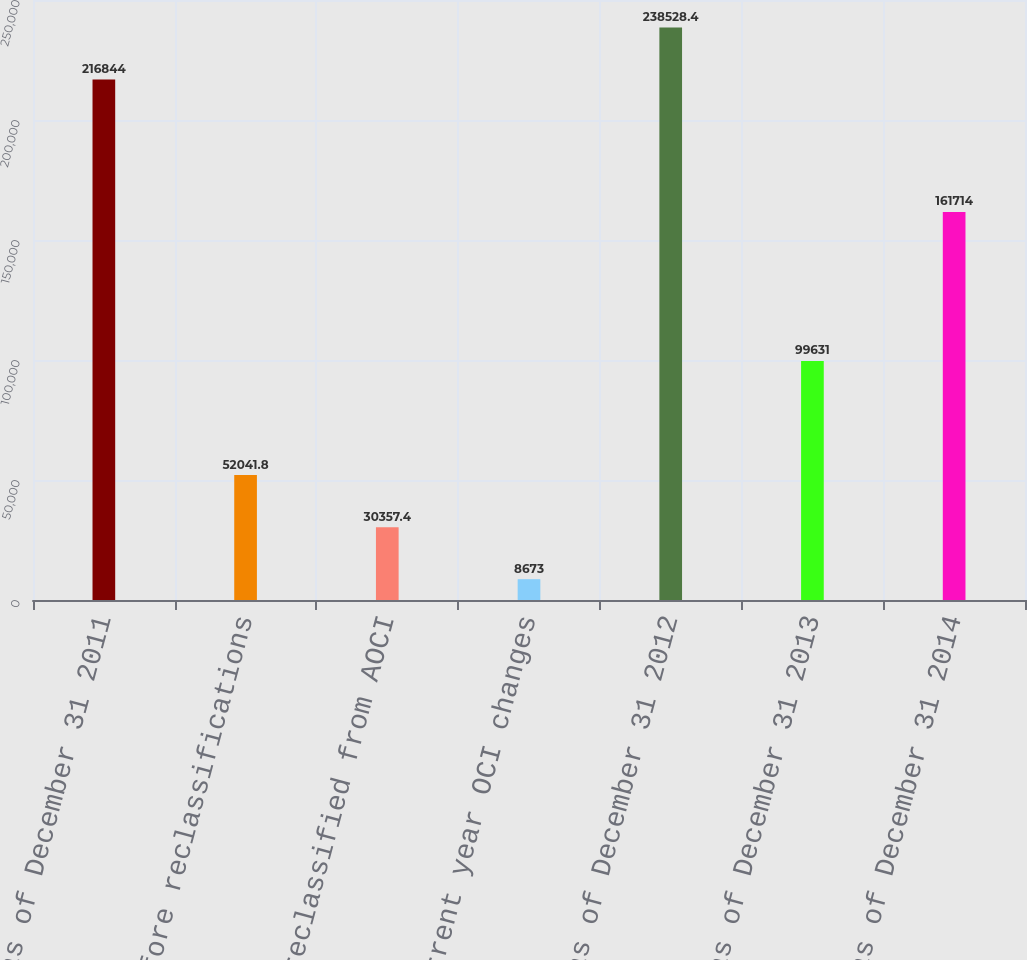<chart> <loc_0><loc_0><loc_500><loc_500><bar_chart><fcel>Balance as of December 31 2011<fcel>before reclassifications<fcel>Amounts reclassified from AOCI<fcel>Net current year OCI changes<fcel>Balance as of December 31 2012<fcel>Balance as of December 31 2013<fcel>Balance as of December 31 2014<nl><fcel>216844<fcel>52041.8<fcel>30357.4<fcel>8673<fcel>238528<fcel>99631<fcel>161714<nl></chart> 